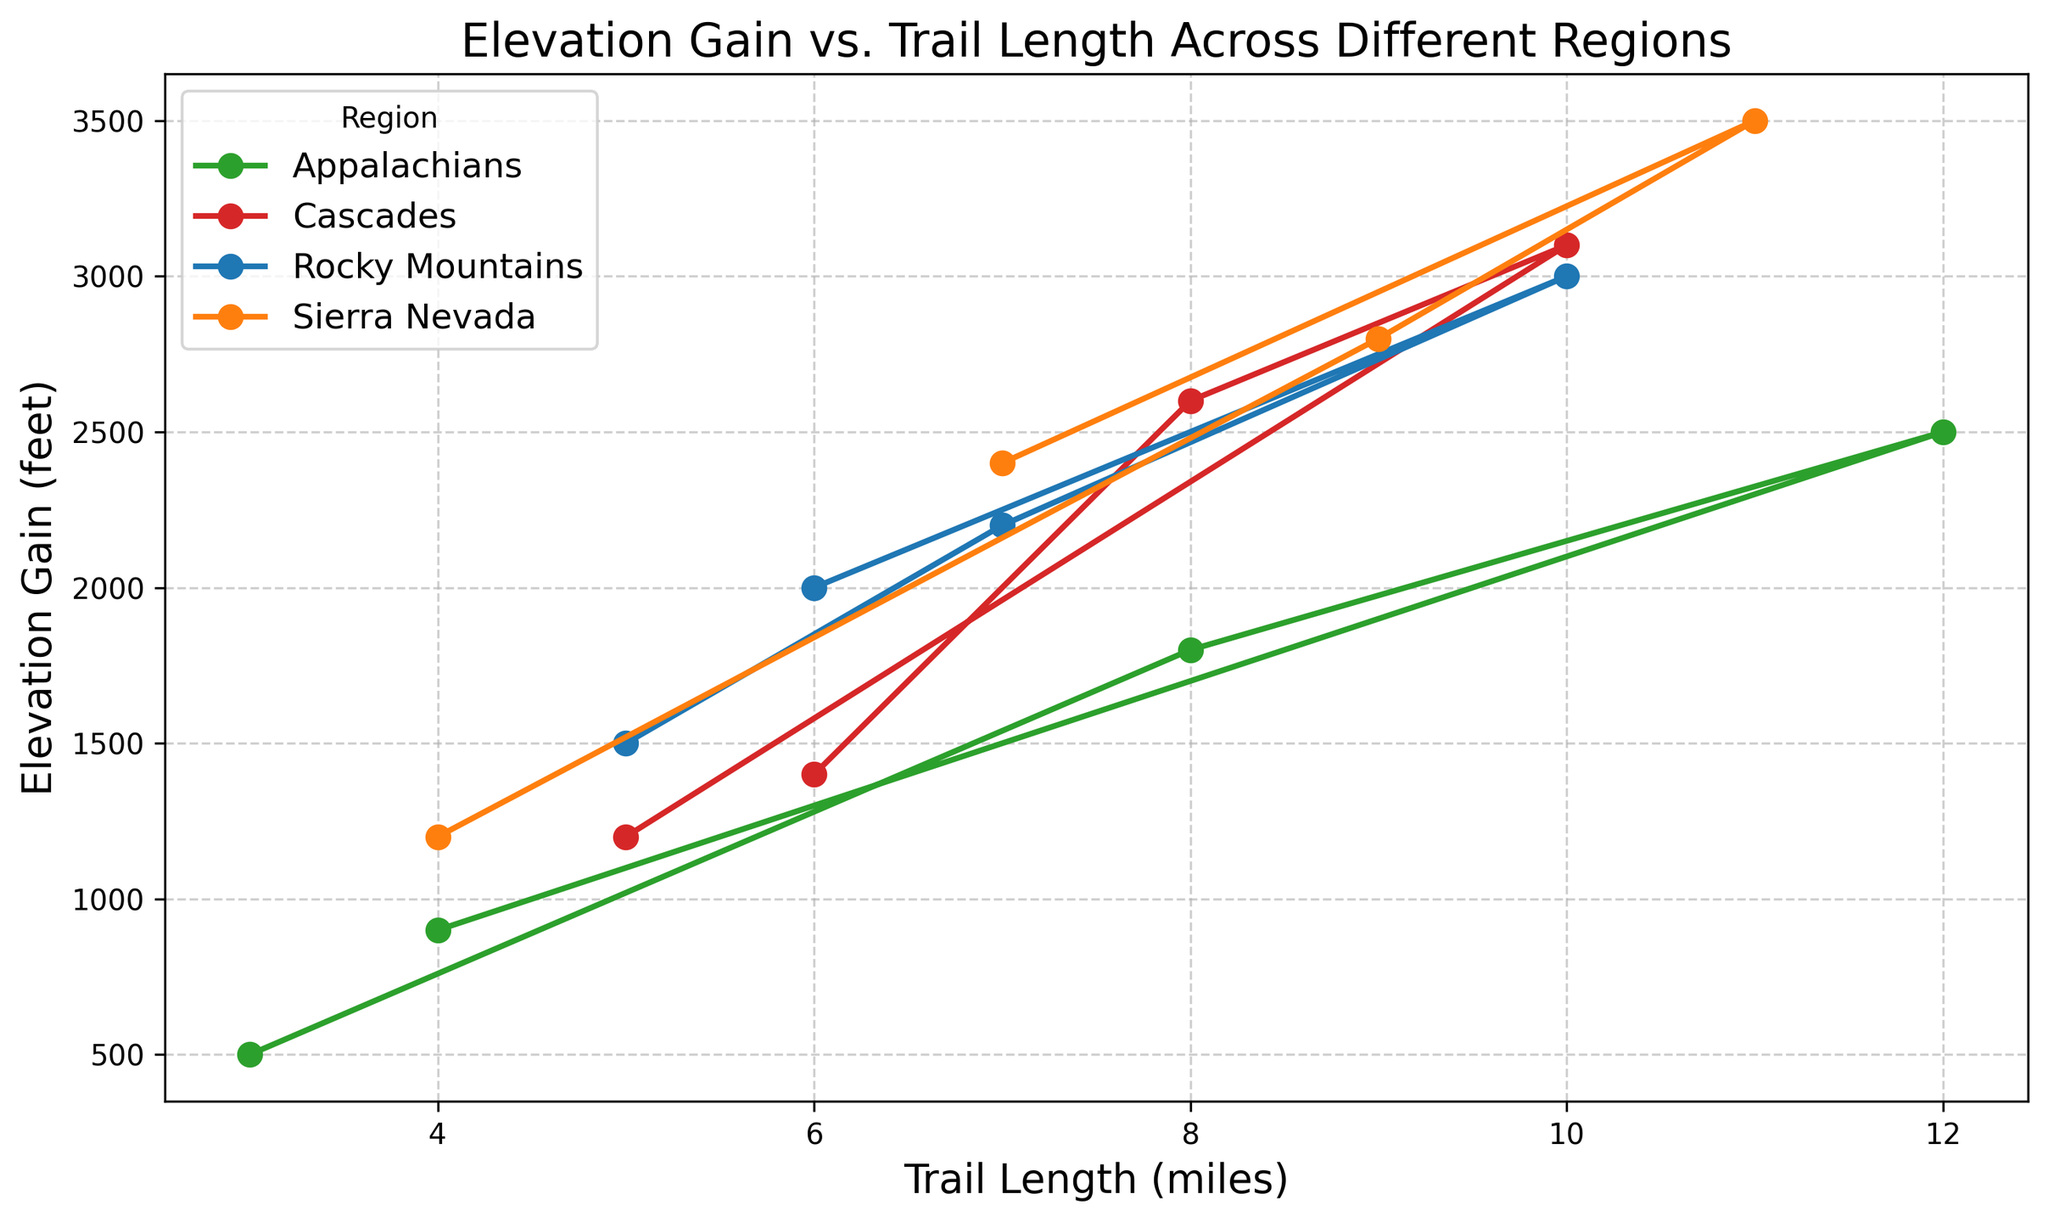Which region shows the highest elevation gain for a 10-mile trail? To find this, we look at the data points for the 10-mile trails and compare their elevation gains. The regions with 10-mile trails are the Rocky Mountains (3000 feet), Appalachians (2500 feet), Sierra Nevada (3500 feet), and Cascades (3100 feet). The highest elevation gain is in Sierra Nevada with 3500 feet.
Answer: Sierra Nevada Which region has the highest average elevation gain across its trails? Calculate the average elevation gain for each region by summing the elevation gains of all trails in that region and dividing by the number of trails. For the Rocky Mountains, the average is (1500 + 2200 + 3000 + 2000)/4 = 2175 feet. For the Appalachians, it is (500 + 1800 + 2500 + 900)/4 = 1425 feet. For the Sierra Nevada, it is (1200 + 2800 + 3500 + 2400)/4 = 2475 feet. For the Cascades, it is (1400 + 2600 + 3100 + 1200)/4 = 2075 feet. The highest average elevation gain is in Sierra Nevada with 2475 feet.
Answer: Sierra Nevada Which region's trails show the greatest variation in elevation gain? Observe the range of elevation gains (difference between maximum and minimum) for each region. The Rocky Mountains range from 1500 to 3000 feet (range is 1500 feet). The Appalachians range from 500 to 2500 feet (range is 2000 feet). The Sierra Nevada range from 1200 to 3500 feet (range is 2300 feet). The Cascades range from 1200 to 3100 feet (range is 1900 feet). Thus, the Sierra Nevada has the greatest variation in elevation gain with a range of 2300 feet.
Answer: Sierra Nevada What is the total elevation gain of the Rocky Mountain trails combined? Sum the elevation gains of all trails in the Rocky Mountains: 1500 (Trail A) + 2200 (Trail B) + 3000 (Trail C) + 2000 (Trail M) = 8700 feet.
Answer: 8700 feet Which trail has the steepest gradient in the Sierra Nevada region? The steepest gradient is calculated by the ratio of elevation gain to trail length. Compute this for each trail in Sierra Nevada: Trail G: 1200/4 = 300 feet per mile, Trail H: 2800/9 = ~311 feet per mile, Trail I: 3500/11 = ~318 feet per mile, Trail O: 2400/7 = ~343 feet per mile. Trail O has the steepest gradient.
Answer: Trail O In the Cascades, how does the elevation gain of the shortest trail compare to the longest trail? The shortest trail in the Cascades is Trail P (5 miles) with an elevation gain of 1200 feet. The longest is Trail L (10 miles) with an elevation gain of 3100 feet. The elevation gain of the longest trail is over twice as much as that of the shortest trail.
Answer: Over twice as much How does the average trail length in the Rocky Mountains compare to that in the Appalachians? Calculate the average trail length for each region. For the Rocky Mountains: (5 + 7 + 10 + 6)/4 = 7 miles. For the Appalachians: (3 + 8 + 12 + 4)/4 = 6.75 miles. The average trail length in the Rocky Mountains is slightly higher.
Answer: Slightly higher Which region has the smallest trail length but the highest elevation gain? Compare both the trail lengths and elevation gains for the smallest trail in each region. For the Rocky Mountains: Trail A (5 miles, 1500 feet). For the Appalachians: Trail D (3 miles, 500 feet). For Sierra Nevada: Trail G (4 miles, 1200 feet). For Cascades: Trail P (5 miles, 1200 feet). The smallest trail with the highest elevation gain is Trail A in the Rocky Mountains (1500 feet).
Answer: Rocky Mountains What is the elevation gain difference between the longest trails in Sierra Nevada and the Appalachians? Identify the longest trails and their elevation gains: Sierra Nevada’s Trail I (11 miles, 3500 feet) and Appalachians' Trail F (12 miles, 2500 feet). The difference in elevation gain is 3500 - 2500 = 1000 feet.
Answer: 1000 feet 